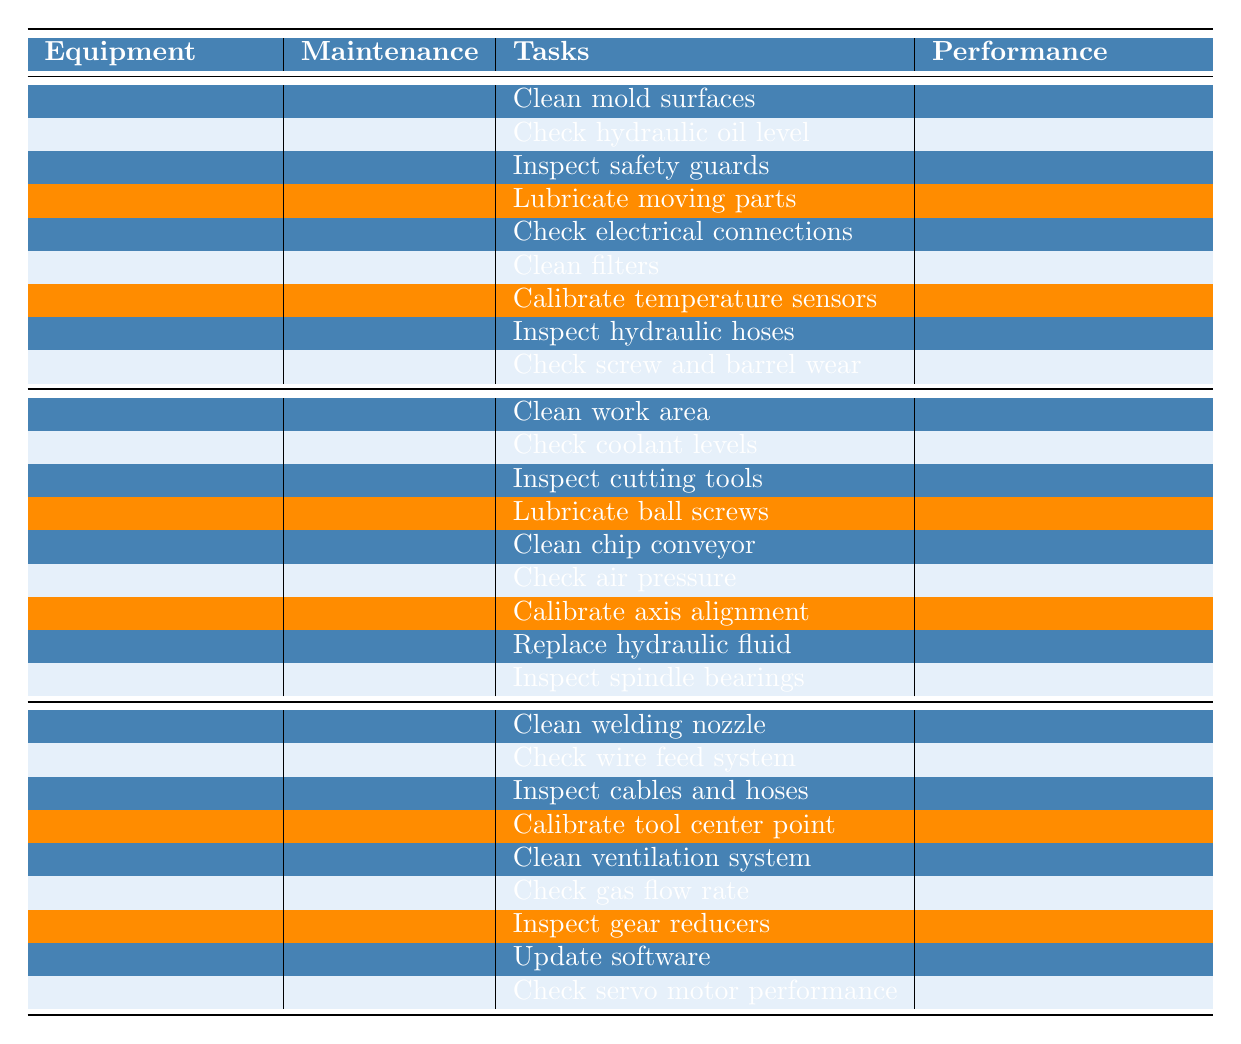What is the uptime of the Injection Molding Machine? The table indicates the uptime for the Injection Molding Machine listed under its performance section. The uptime is specified as 95%.
Answer: 95% What tasks are performed during the weekly maintenance of the CNC Milling Machine? The table shows that the weekly maintenance for the CNC Milling Machine includes three tasks: Lubricate ball screws, Clean chip conveyor, and Check air pressure.
Answer: Lubricate ball screws, Clean chip conveyor, Check air pressure Is the weld quality of the Robotic Welding Arm greater than 90%? The table states the weld quality for the Robotic Welding Arm is a 98% pass rate, which is indeed greater than 90%.
Answer: Yes What is the average output rate between the Injection Molding Machine and the CNC Milling Machine? The output rate of the Injection Molding Machine is given as 450 parts/hour, while the CNC Milling Machine performance does not specify an output rate but instead provides cutting speed. To find the average output rate, we can only take the Injection Molding Machine's output into account since the CNC Milling Machine's data is non-comparable here. Therefore, the average considering only the referenced output is 450 parts/hour.
Answer: 450 parts/hour Which machine has the highest uptime? Reviewing the uptime values, the Injection Molding Machine has 95%, the CNC Milling Machine has 92%, and the Robotic Welding Arm has 97%. The highest uptime is held by the Robotic Welding Arm.
Answer: Robotic Welding Arm How many tasks are included in the monthly maintenance for the Injection Molding Machine? The table lists three tasks under the monthly maintenance for the Injection Molding Machine: Calibrate temperature sensors, Inspect hydraulic hoses, and Check screw and barrel wear. Thus, there are a total of three tasks.
Answer: 3 tasks If the CNC Milling Machine was in operation for 12 hours, how many parts would it produce approximating its cutting speed? The cutting speed for the CNC Milling Machine is provided in RPM (10,000 RPM). However, without an output per minute, deducing the total quantity is not straightforward as it does not align directly with parts produced. Thus, while cutting speed is not directly adaptable to total parts within a 12-hour frame, an approximation cannot be calculated with available data accurately.
Answer: Not calculable directly What maintenance type has the most tasks for the Robotic Welding Arm? In the table, the Robotic Welding Arm indicates that for each maintenance period (Daily, Weekly, Monthly), there are three tasks listed. Hence, all maintenance types for the Robotic Welding Arm have an equal number of tasks.
Answer: Equal tasks for all types Compare the defect rate of the Injection Molding Machine with the weld quality of the Robotic Welding Arm. The defect rate of the Injection Molding Machine is 0.5%, while the weld quality for the Robotic Welding Arm is indicated as a 98% pass rate. In this context, a lower defect rate corresponds to higher overall performance relative to one another. The comparison reveals that the Robotic Welding Arm shows superior performance with a pass rate significantly above the defect rate of the Injection Molding Machine.
Answer: Robotic Welding Arm shows superior performance 